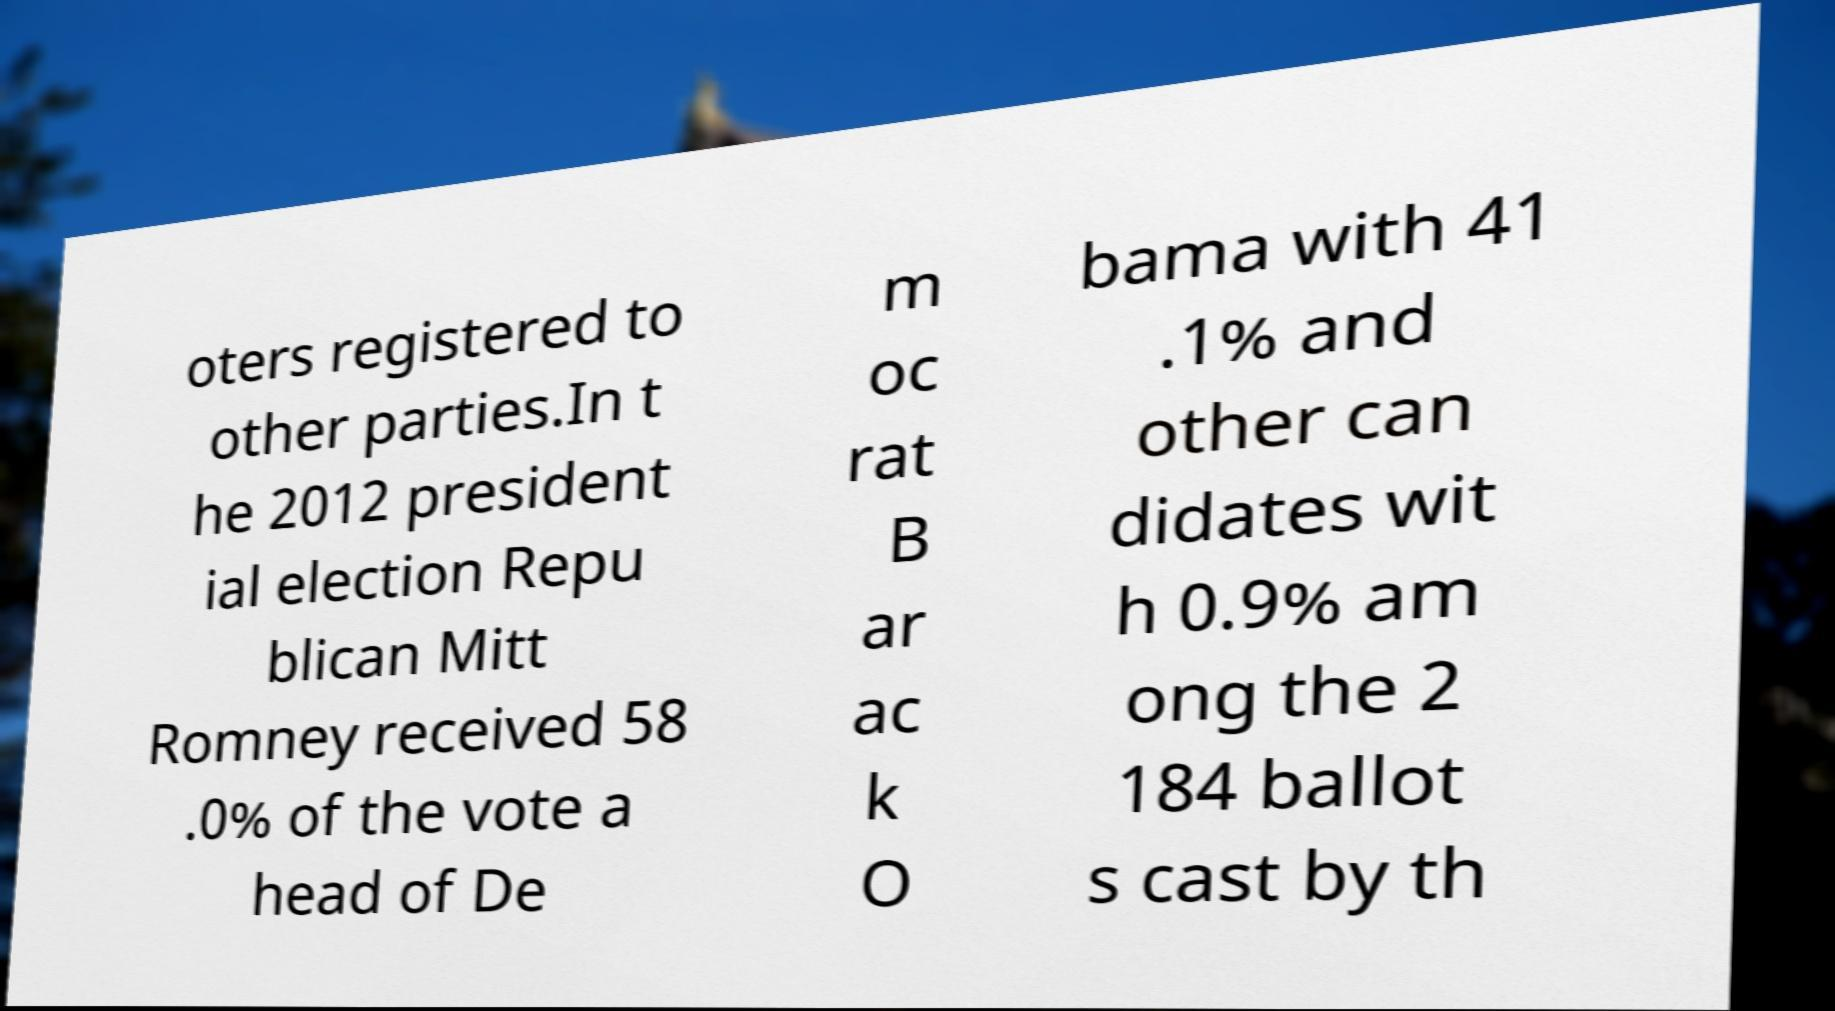For documentation purposes, I need the text within this image transcribed. Could you provide that? oters registered to other parties.In t he 2012 president ial election Repu blican Mitt Romney received 58 .0% of the vote a head of De m oc rat B ar ac k O bama with 41 .1% and other can didates wit h 0.9% am ong the 2 184 ballot s cast by th 